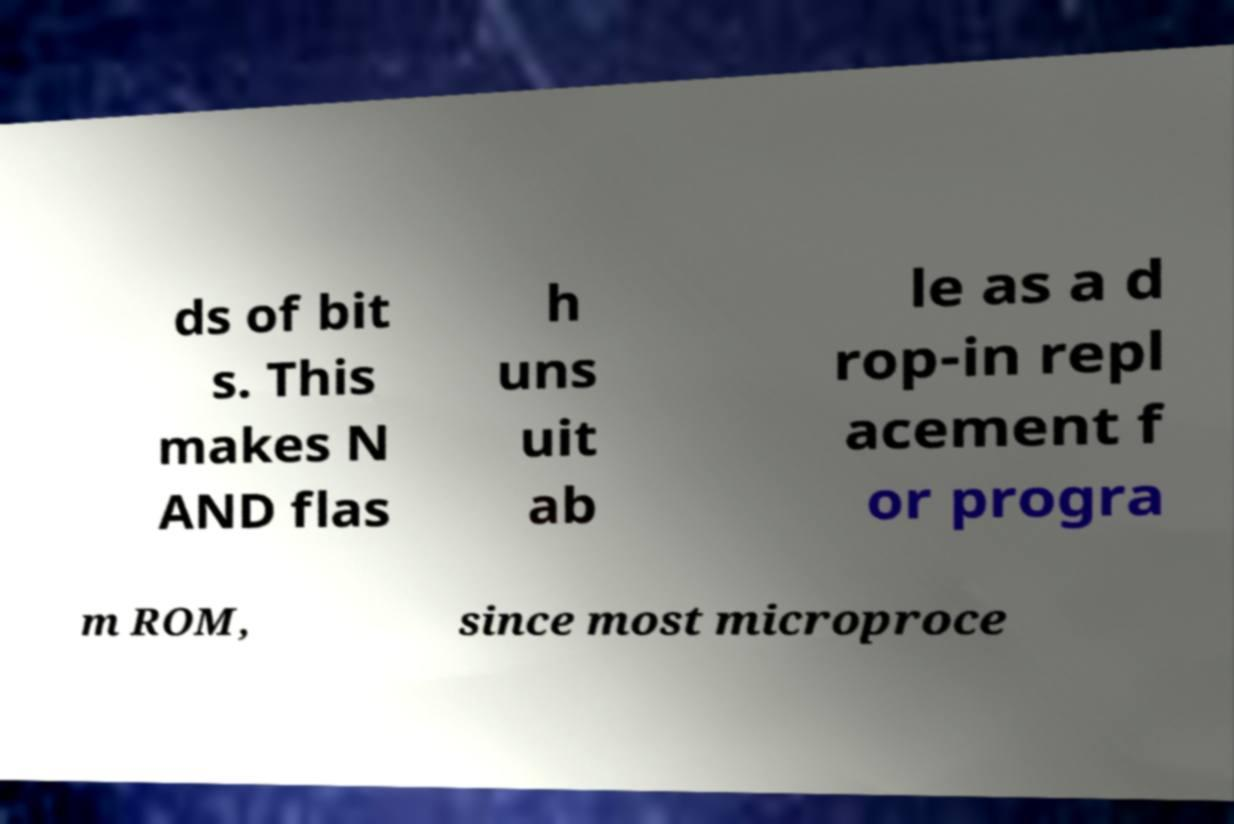What messages or text are displayed in this image? I need them in a readable, typed format. ds of bit s. This makes N AND flas h uns uit ab le as a d rop-in repl acement f or progra m ROM, since most microproce 